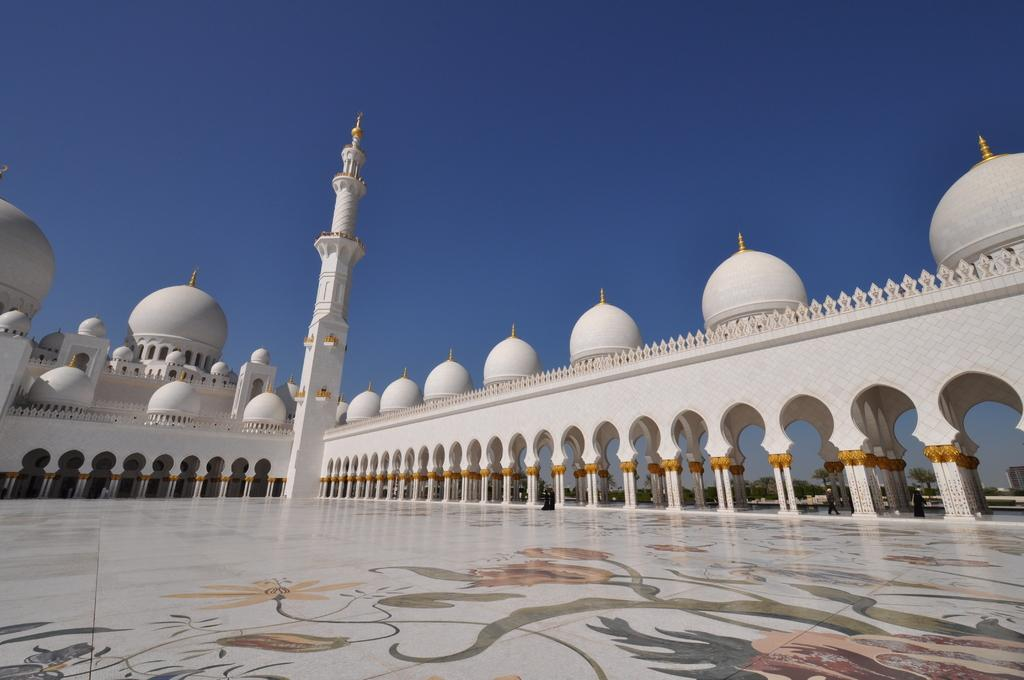What type of building is in the image? There is a mosque in the image. Are there any people in the image? Yes, there are people in the image. What is at the bottom of the image? There is a floor at the bottom of the image. What can be seen in the background of the image? There is sky and trees visible in the background of the image. What force is causing the mosque to burst in the image? There is no force causing the mosque to burst in the image; it is a stable building. 